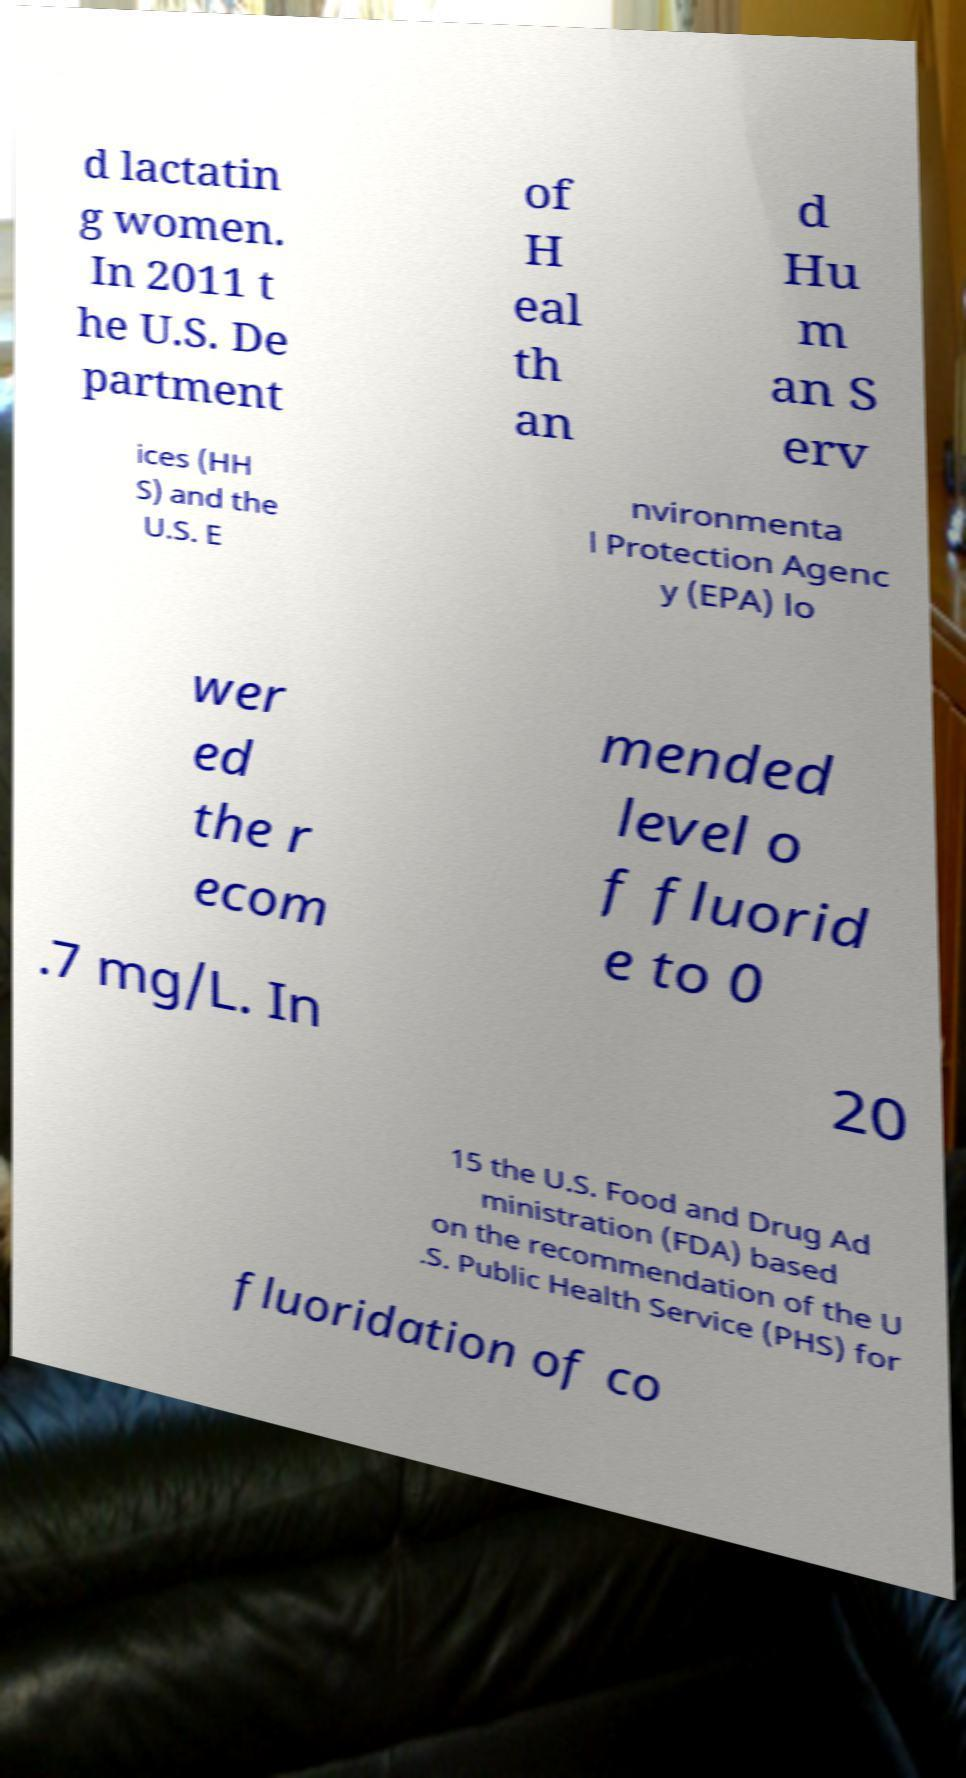I need the written content from this picture converted into text. Can you do that? d lactatin g women. In 2011 t he U.S. De partment of H eal th an d Hu m an S erv ices (HH S) and the U.S. E nvironmenta l Protection Agenc y (EPA) lo wer ed the r ecom mended level o f fluorid e to 0 .7 mg/L. In 20 15 the U.S. Food and Drug Ad ministration (FDA) based on the recommendation of the U .S. Public Health Service (PHS) for fluoridation of co 